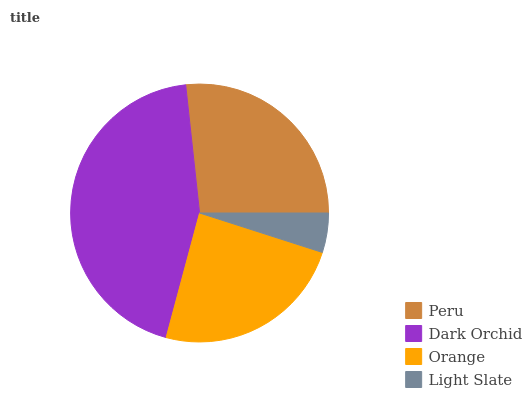Is Light Slate the minimum?
Answer yes or no. Yes. Is Dark Orchid the maximum?
Answer yes or no. Yes. Is Orange the minimum?
Answer yes or no. No. Is Orange the maximum?
Answer yes or no. No. Is Dark Orchid greater than Orange?
Answer yes or no. Yes. Is Orange less than Dark Orchid?
Answer yes or no. Yes. Is Orange greater than Dark Orchid?
Answer yes or no. No. Is Dark Orchid less than Orange?
Answer yes or no. No. Is Peru the high median?
Answer yes or no. Yes. Is Orange the low median?
Answer yes or no. Yes. Is Dark Orchid the high median?
Answer yes or no. No. Is Dark Orchid the low median?
Answer yes or no. No. 